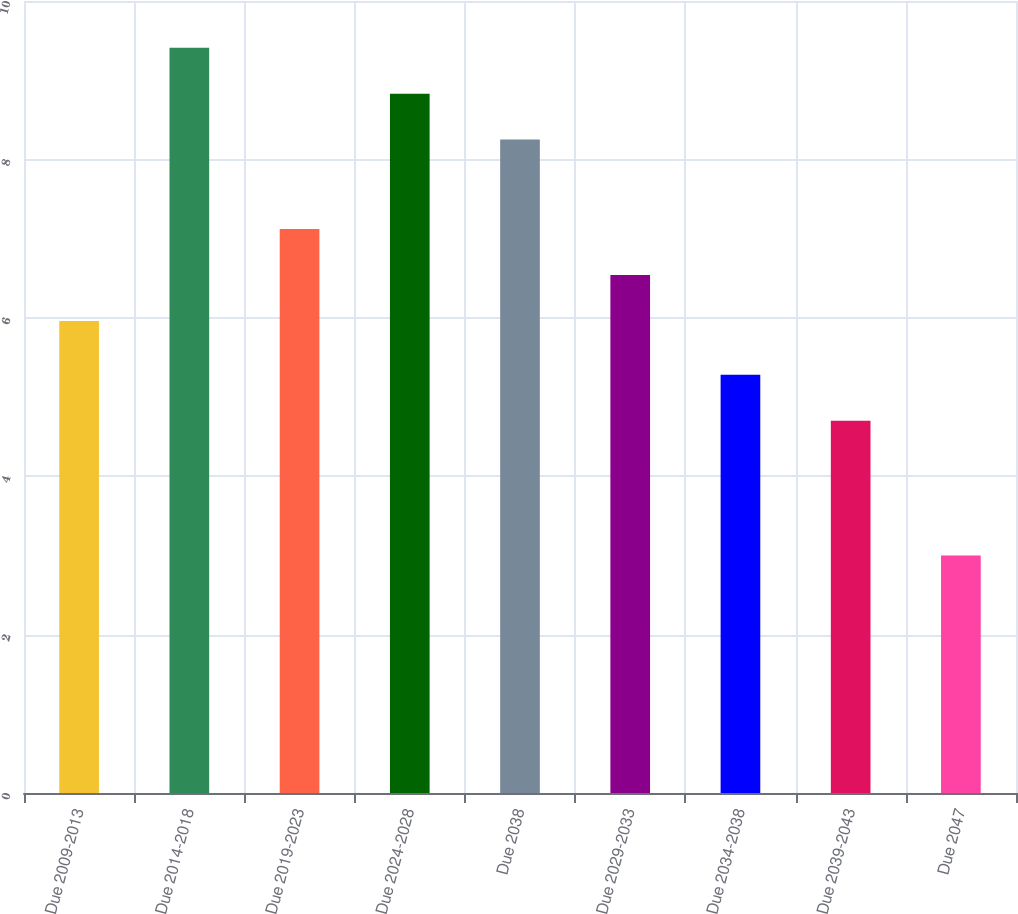<chart> <loc_0><loc_0><loc_500><loc_500><bar_chart><fcel>Due 2009-2013<fcel>Due 2014-2018<fcel>Due 2019-2023<fcel>Due 2024-2028<fcel>Due 2038<fcel>Due 2029-2033<fcel>Due 2034-2038<fcel>Due 2039-2043<fcel>Due 2047<nl><fcel>5.96<fcel>9.41<fcel>7.12<fcel>8.83<fcel>8.25<fcel>6.54<fcel>5.28<fcel>4.7<fcel>3<nl></chart> 